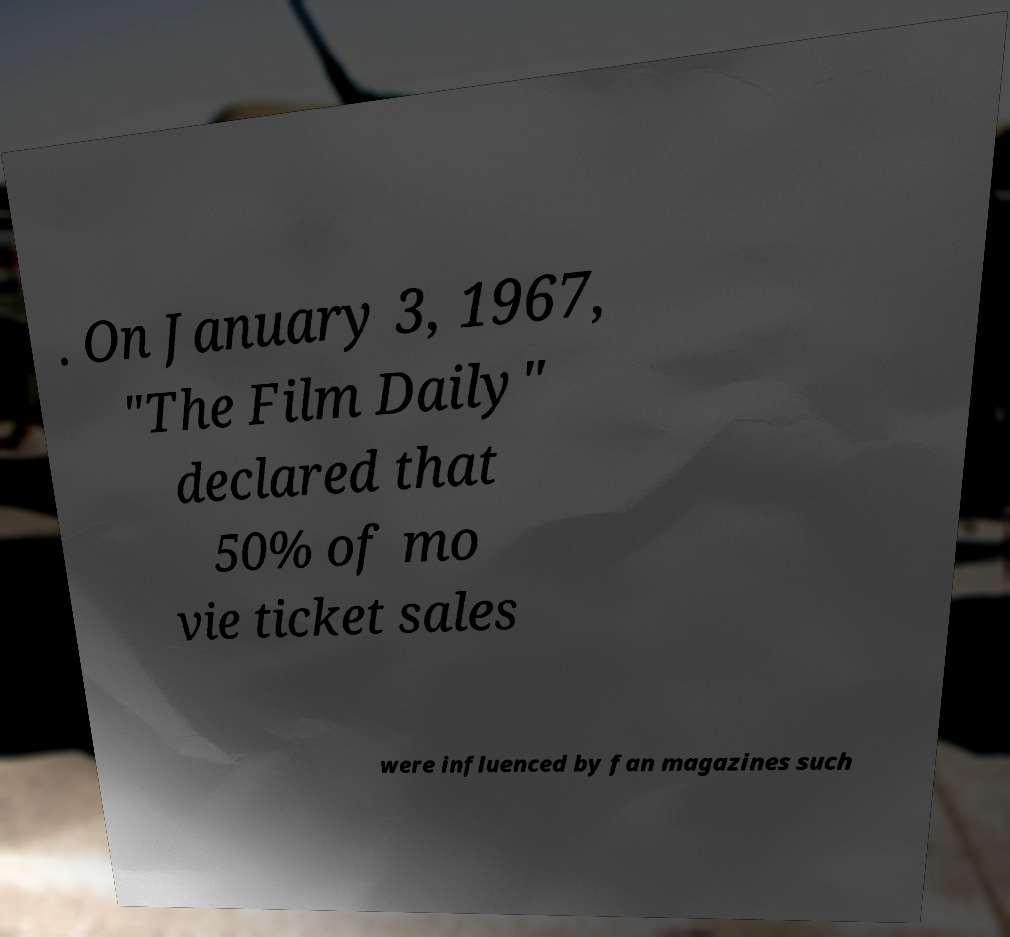Can you accurately transcribe the text from the provided image for me? . On January 3, 1967, "The Film Daily" declared that 50% of mo vie ticket sales were influenced by fan magazines such 